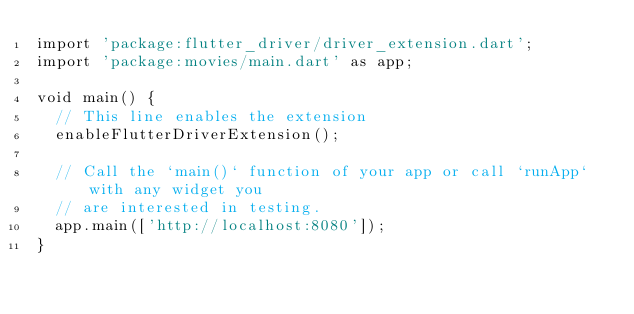Convert code to text. <code><loc_0><loc_0><loc_500><loc_500><_Dart_>import 'package:flutter_driver/driver_extension.dart';
import 'package:movies/main.dart' as app;

void main() {
  // This line enables the extension
  enableFlutterDriverExtension();

  // Call the `main()` function of your app or call `runApp` with any widget you
  // are interested in testing.
  app.main(['http://localhost:8080']);
}
</code> 